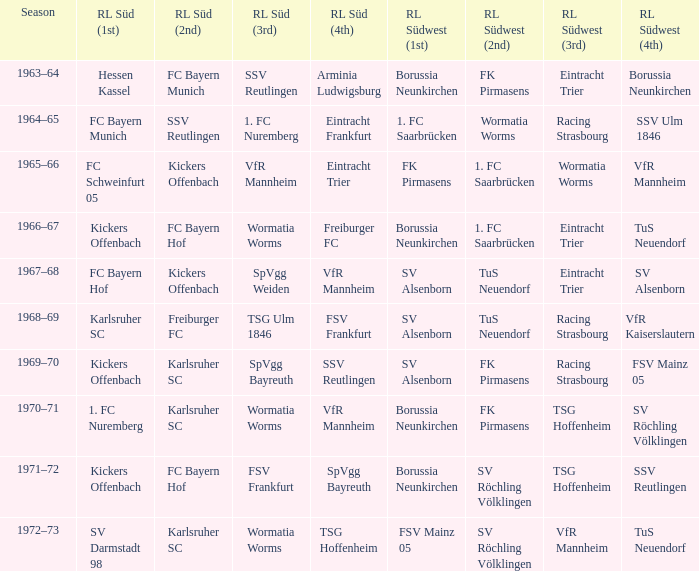Who was RL Süd (1st) when FK Pirmasens was RL Südwest (1st)? FC Schweinfurt 05. 